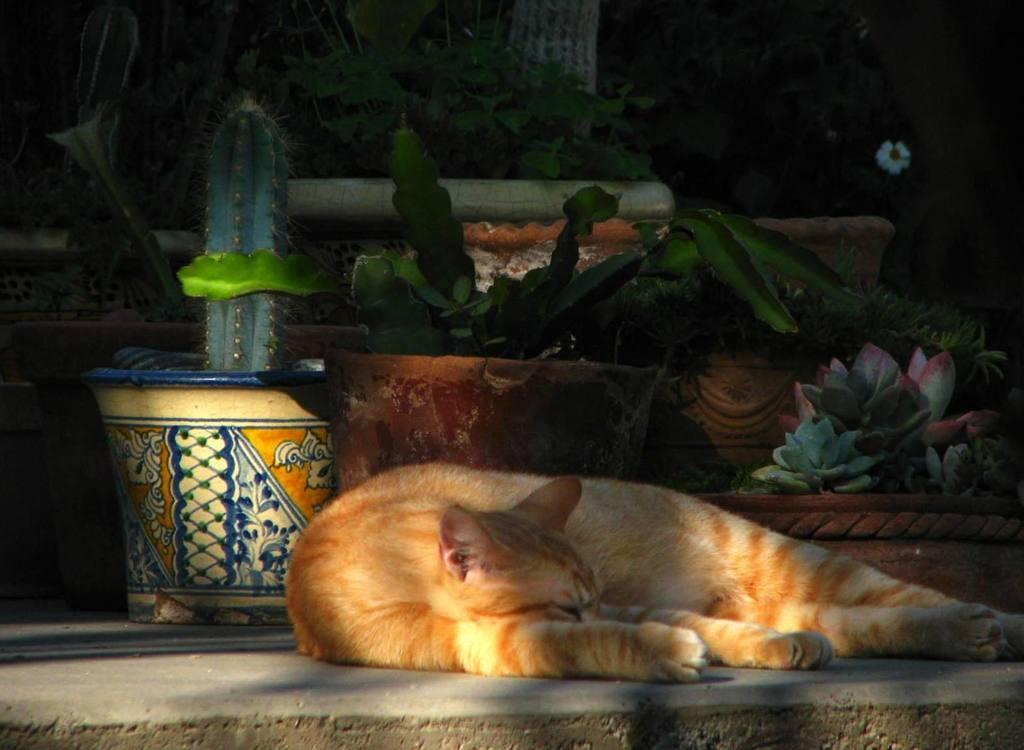What type of animal can be seen in the image? There is a cat in the image. What is the cat doing in the image? The cat is laying on the ground. Can you describe the color of the cat? The cat is white and brown in color. What type of vegetation is present in the image? There are plants in pots and flowers visible in the image. How many houses can be seen connected by a bridge in the image? There are no houses or bridges present in the image; it features a cat laying on the ground and plants in pots with flowers. 